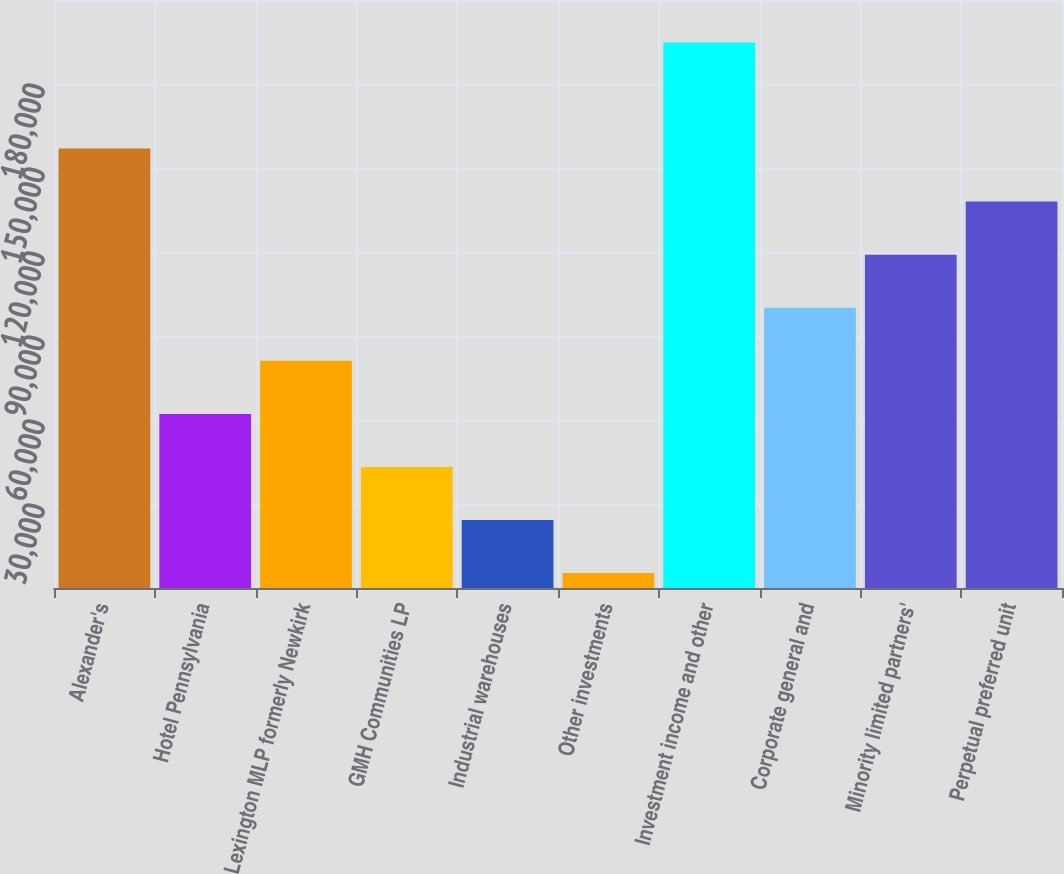Convert chart to OTSL. <chart><loc_0><loc_0><loc_500><loc_500><bar_chart><fcel>Alexander's<fcel>Hotel Pennsylvania<fcel>Lexington MLP formerly Newkirk<fcel>GMH Communities LP<fcel>Industrial warehouses<fcel>Other investments<fcel>Investment income and other<fcel>Corporate general and<fcel>Minority limited partners'<fcel>Perpetual preferred unit<nl><fcel>156945<fcel>62178.6<fcel>81131.8<fcel>43225.4<fcel>24272.2<fcel>5319<fcel>194851<fcel>100085<fcel>119038<fcel>137991<nl></chart> 